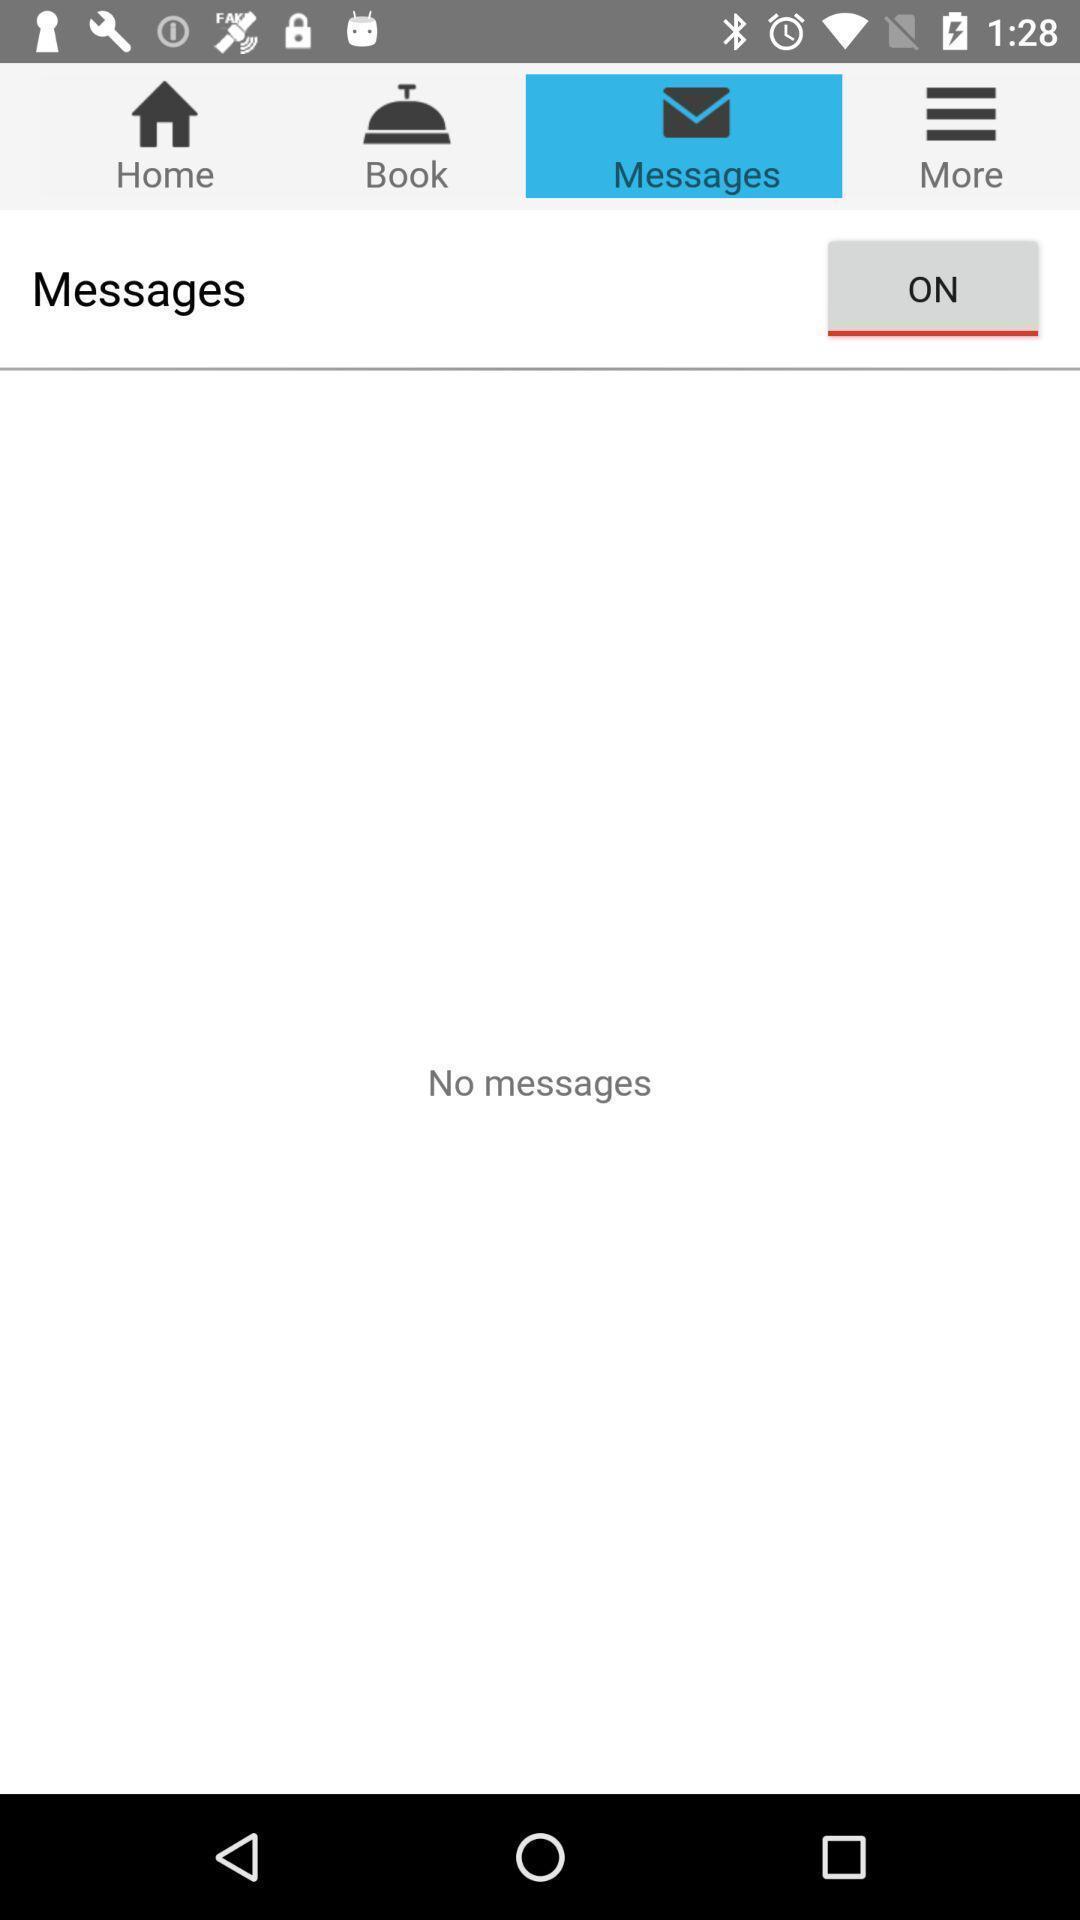What can you discern from this picture? Screen showing messages page. 